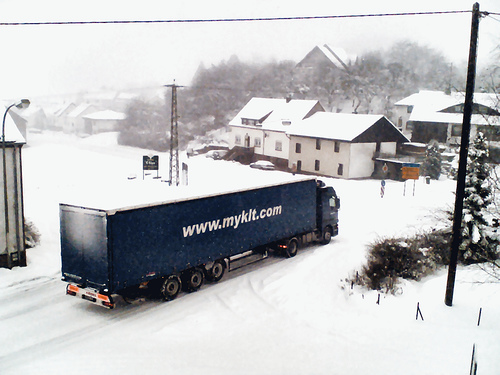What observations can be made about the human activity in this environment? There is minimal human activity visible in the image. A solitary figure can be seen walking in the distance, likely braving the cold conditions. The snow-covered landscape and lack of bustling activity suggest that people may be staying indoors to avoid the inclement weather. 